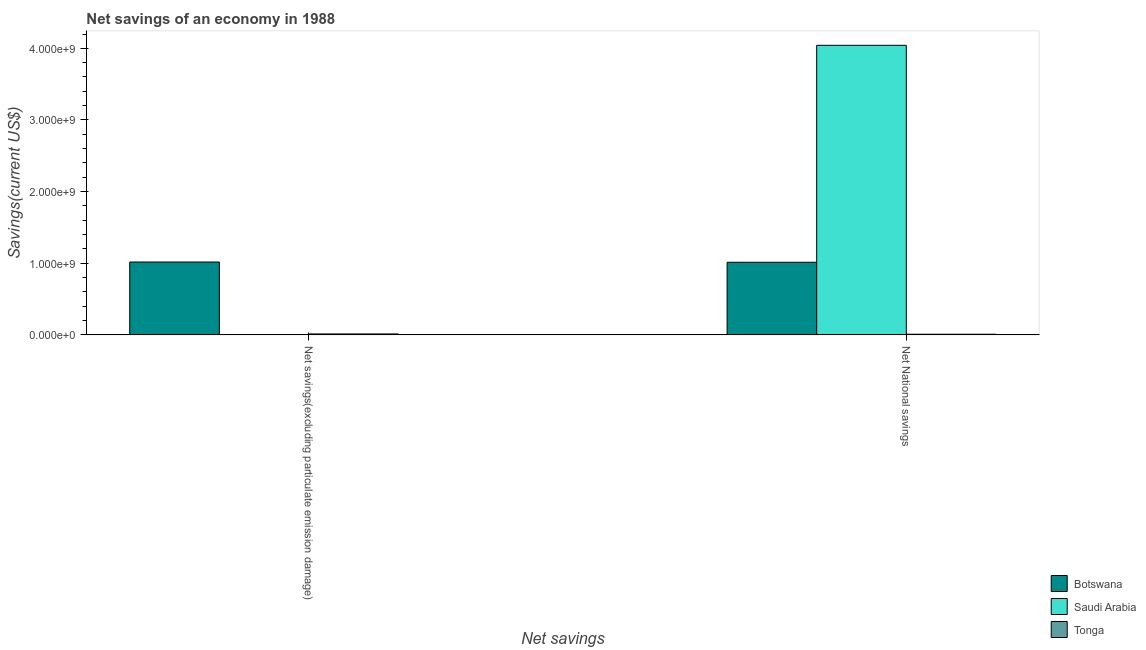How many bars are there on the 2nd tick from the left?
Your answer should be very brief. 3. How many bars are there on the 2nd tick from the right?
Offer a very short reply. 2. What is the label of the 2nd group of bars from the left?
Your response must be concise. Net National savings. Across all countries, what is the maximum net savings(excluding particulate emission damage)?
Keep it short and to the point. 1.02e+09. Across all countries, what is the minimum net national savings?
Keep it short and to the point. 9.19e+06. In which country was the net national savings maximum?
Offer a terse response. Saudi Arabia. What is the total net national savings in the graph?
Give a very brief answer. 5.07e+09. What is the difference between the net national savings in Saudi Arabia and that in Tonga?
Provide a short and direct response. 4.03e+09. What is the difference between the net savings(excluding particulate emission damage) in Botswana and the net national savings in Saudi Arabia?
Your response must be concise. -3.03e+09. What is the average net savings(excluding particulate emission damage) per country?
Offer a terse response. 3.43e+08. What is the difference between the net savings(excluding particulate emission damage) and net national savings in Botswana?
Keep it short and to the point. 3.18e+06. In how many countries, is the net national savings greater than 3200000000 US$?
Your response must be concise. 1. What is the ratio of the net national savings in Tonga to that in Saudi Arabia?
Keep it short and to the point. 0. Is the net savings(excluding particulate emission damage) in Botswana less than that in Tonga?
Provide a short and direct response. No. In how many countries, is the net national savings greater than the average net national savings taken over all countries?
Your response must be concise. 1. Are all the bars in the graph horizontal?
Offer a terse response. No. What is the difference between two consecutive major ticks on the Y-axis?
Ensure brevity in your answer.  1.00e+09. Does the graph contain grids?
Your answer should be compact. No. How many legend labels are there?
Keep it short and to the point. 3. What is the title of the graph?
Make the answer very short. Net savings of an economy in 1988. Does "Uzbekistan" appear as one of the legend labels in the graph?
Keep it short and to the point. No. What is the label or title of the X-axis?
Provide a short and direct response. Net savings. What is the label or title of the Y-axis?
Your response must be concise. Savings(current US$). What is the Savings(current US$) of Botswana in Net savings(excluding particulate emission damage)?
Provide a succinct answer. 1.02e+09. What is the Savings(current US$) in Saudi Arabia in Net savings(excluding particulate emission damage)?
Give a very brief answer. 0. What is the Savings(current US$) in Tonga in Net savings(excluding particulate emission damage)?
Your response must be concise. 1.33e+07. What is the Savings(current US$) in Botswana in Net National savings?
Make the answer very short. 1.01e+09. What is the Savings(current US$) in Saudi Arabia in Net National savings?
Provide a short and direct response. 4.04e+09. What is the Savings(current US$) in Tonga in Net National savings?
Provide a short and direct response. 9.19e+06. Across all Net savings, what is the maximum Savings(current US$) of Botswana?
Keep it short and to the point. 1.02e+09. Across all Net savings, what is the maximum Savings(current US$) in Saudi Arabia?
Provide a succinct answer. 4.04e+09. Across all Net savings, what is the maximum Savings(current US$) in Tonga?
Provide a short and direct response. 1.33e+07. Across all Net savings, what is the minimum Savings(current US$) in Botswana?
Your answer should be very brief. 1.01e+09. Across all Net savings, what is the minimum Savings(current US$) in Saudi Arabia?
Keep it short and to the point. 0. Across all Net savings, what is the minimum Savings(current US$) of Tonga?
Make the answer very short. 9.19e+06. What is the total Savings(current US$) in Botswana in the graph?
Your answer should be very brief. 2.03e+09. What is the total Savings(current US$) in Saudi Arabia in the graph?
Give a very brief answer. 4.04e+09. What is the total Savings(current US$) of Tonga in the graph?
Provide a short and direct response. 2.25e+07. What is the difference between the Savings(current US$) in Botswana in Net savings(excluding particulate emission damage) and that in Net National savings?
Give a very brief answer. 3.18e+06. What is the difference between the Savings(current US$) in Tonga in Net savings(excluding particulate emission damage) and that in Net National savings?
Make the answer very short. 4.15e+06. What is the difference between the Savings(current US$) in Botswana in Net savings(excluding particulate emission damage) and the Savings(current US$) in Saudi Arabia in Net National savings?
Give a very brief answer. -3.03e+09. What is the difference between the Savings(current US$) in Botswana in Net savings(excluding particulate emission damage) and the Savings(current US$) in Tonga in Net National savings?
Your answer should be compact. 1.01e+09. What is the average Savings(current US$) of Botswana per Net savings?
Your answer should be compact. 1.02e+09. What is the average Savings(current US$) of Saudi Arabia per Net savings?
Offer a terse response. 2.02e+09. What is the average Savings(current US$) in Tonga per Net savings?
Your answer should be compact. 1.13e+07. What is the difference between the Savings(current US$) in Botswana and Savings(current US$) in Tonga in Net savings(excluding particulate emission damage)?
Ensure brevity in your answer.  1.00e+09. What is the difference between the Savings(current US$) in Botswana and Savings(current US$) in Saudi Arabia in Net National savings?
Ensure brevity in your answer.  -3.03e+09. What is the difference between the Savings(current US$) of Botswana and Savings(current US$) of Tonga in Net National savings?
Give a very brief answer. 1.00e+09. What is the difference between the Savings(current US$) in Saudi Arabia and Savings(current US$) in Tonga in Net National savings?
Give a very brief answer. 4.03e+09. What is the ratio of the Savings(current US$) in Tonga in Net savings(excluding particulate emission damage) to that in Net National savings?
Keep it short and to the point. 1.45. What is the difference between the highest and the second highest Savings(current US$) of Botswana?
Your response must be concise. 3.18e+06. What is the difference between the highest and the second highest Savings(current US$) in Tonga?
Offer a very short reply. 4.15e+06. What is the difference between the highest and the lowest Savings(current US$) in Botswana?
Provide a succinct answer. 3.18e+06. What is the difference between the highest and the lowest Savings(current US$) in Saudi Arabia?
Keep it short and to the point. 4.04e+09. What is the difference between the highest and the lowest Savings(current US$) of Tonga?
Provide a succinct answer. 4.15e+06. 